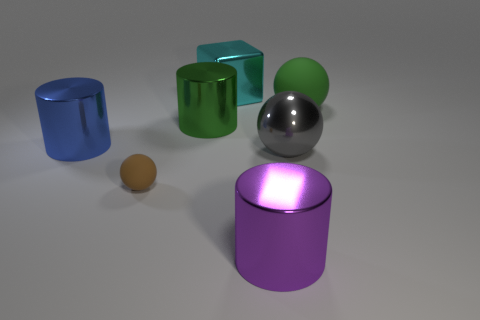If this was a scene from a film, what mood or atmosphere do you think it's conveying? Given the minimalist setup and the cool, soft lighting, the scene conjures a calm and serene atmosphere. The sleek finish on most of the objects and the pristine background impart a futuristic or high-tech aesthetic, which might suggest a setting that is cutting-edge or sophisticated, perfect for a science fiction or modern drama presentation. 